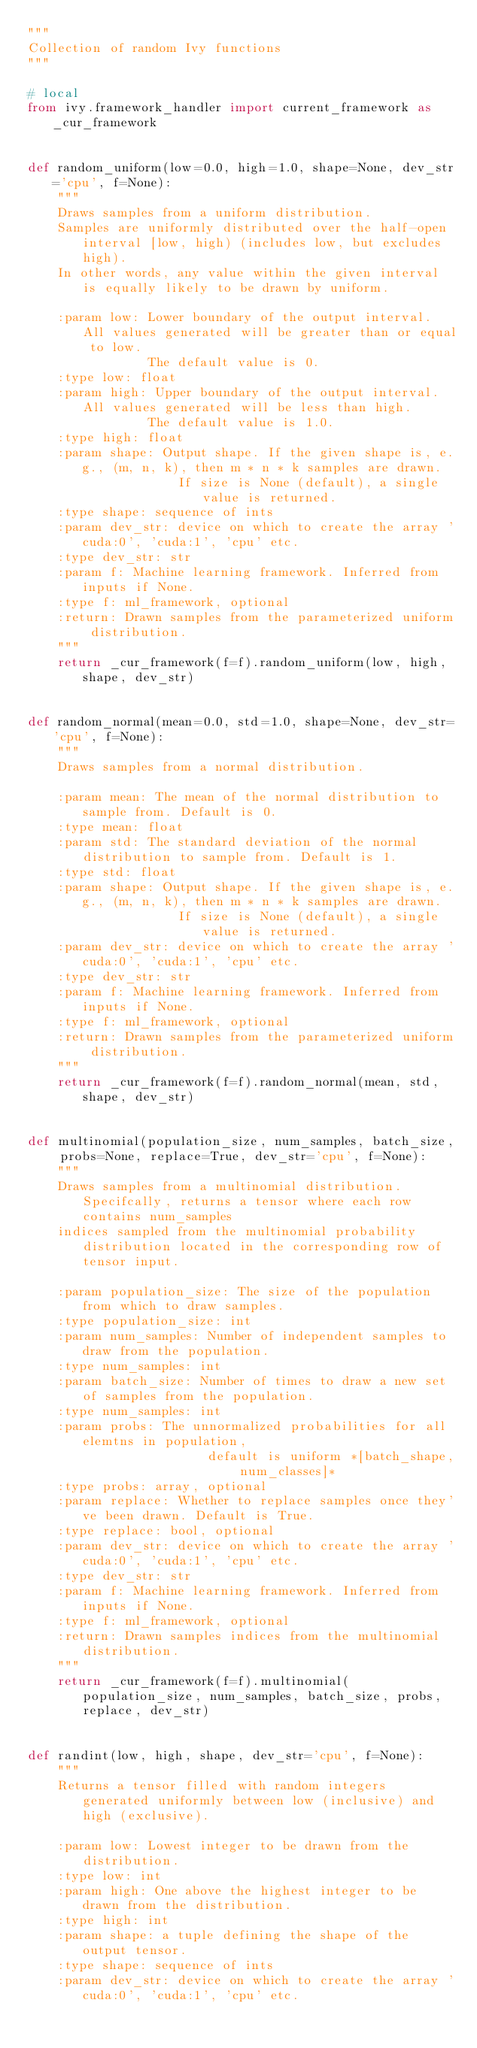Convert code to text. <code><loc_0><loc_0><loc_500><loc_500><_Python_>"""
Collection of random Ivy functions
"""

# local
from ivy.framework_handler import current_framework as _cur_framework


def random_uniform(low=0.0, high=1.0, shape=None, dev_str='cpu', f=None):
    """
    Draws samples from a uniform distribution.
    Samples are uniformly distributed over the half-open interval [low, high) (includes low, but excludes high).
    In other words, any value within the given interval is equally likely to be drawn by uniform.

    :param low: Lower boundary of the output interval. All values generated will be greater than or equal to low.
                The default value is 0.
    :type low: float
    :param high: Upper boundary of the output interval. All values generated will be less than high.
                The default value is 1.0.
    :type high: float
    :param shape: Output shape. If the given shape is, e.g., (m, n, k), then m * n * k samples are drawn.
                    If size is None (default), a single value is returned.
    :type shape: sequence of ints
    :param dev_str: device on which to create the array 'cuda:0', 'cuda:1', 'cpu' etc.
    :type dev_str: str
    :param f: Machine learning framework. Inferred from inputs if None.
    :type f: ml_framework, optional
    :return: Drawn samples from the parameterized uniform distribution.
    """
    return _cur_framework(f=f).random_uniform(low, high, shape, dev_str)


def random_normal(mean=0.0, std=1.0, shape=None, dev_str='cpu', f=None):
    """
    Draws samples from a normal distribution.

    :param mean: The mean of the normal distribution to sample from. Default is 0.
    :type mean: float
    :param std: The standard deviation of the normal distribution to sample from. Default is 1.
    :type std: float
    :param shape: Output shape. If the given shape is, e.g., (m, n, k), then m * n * k samples are drawn.
                    If size is None (default), a single value is returned.
    :param dev_str: device on which to create the array 'cuda:0', 'cuda:1', 'cpu' etc.
    :type dev_str: str
    :param f: Machine learning framework. Inferred from inputs if None.
    :type f: ml_framework, optional
    :return: Drawn samples from the parameterized uniform distribution.
    """
    return _cur_framework(f=f).random_normal(mean, std, shape, dev_str)


def multinomial(population_size, num_samples, batch_size, probs=None, replace=True, dev_str='cpu', f=None):
    """
    Draws samples from a multinomial distribution. Specifcally, returns a tensor where each row contains num_samples
    indices sampled from the multinomial probability distribution located in the corresponding row of tensor input.

    :param population_size: The size of the population from which to draw samples.
    :type population_size: int
    :param num_samples: Number of independent samples to draw from the population.
    :type num_samples: int
    :param batch_size: Number of times to draw a new set of samples from the population.
    :type num_samples: int
    :param probs: The unnormalized probabilities for all elemtns in population,
                        default is uniform *[batch_shape, num_classes]*
    :type probs: array, optional
    :param replace: Whether to replace samples once they've been drawn. Default is True.
    :type replace: bool, optional
    :param dev_str: device on which to create the array 'cuda:0', 'cuda:1', 'cpu' etc.
    :type dev_str: str
    :param f: Machine learning framework. Inferred from inputs if None.
    :type f: ml_framework, optional
    :return: Drawn samples indices from the multinomial distribution.
    """
    return _cur_framework(f=f).multinomial(population_size, num_samples, batch_size, probs, replace, dev_str)


def randint(low, high, shape, dev_str='cpu', f=None):
    """
    Returns a tensor filled with random integers generated uniformly between low (inclusive) and high (exclusive).

    :param low: Lowest integer to be drawn from the distribution.
    :type low: int
    :param high: One above the highest integer to be drawn from the distribution.
    :type high: int
    :param shape: a tuple defining the shape of the output tensor.
    :type shape: sequence of ints
    :param dev_str: device on which to create the array 'cuda:0', 'cuda:1', 'cpu' etc.</code> 